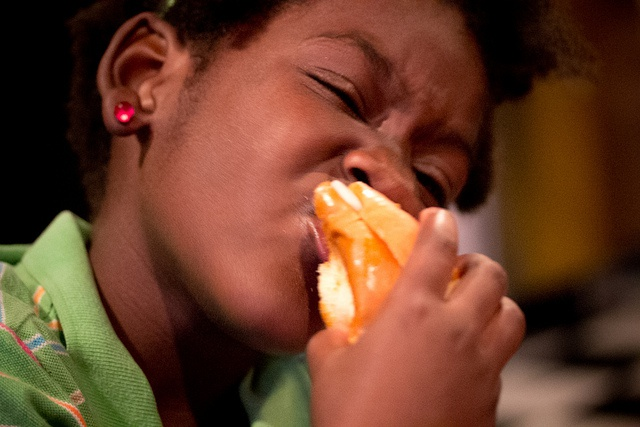Describe the objects in this image and their specific colors. I can see people in black, maroon, and brown tones and hot dog in black, orange, red, and tan tones in this image. 